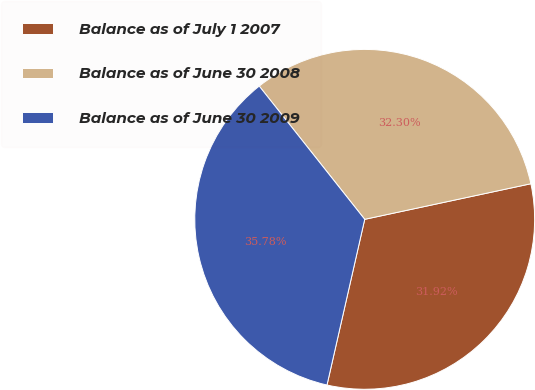<chart> <loc_0><loc_0><loc_500><loc_500><pie_chart><fcel>Balance as of July 1 2007<fcel>Balance as of June 30 2008<fcel>Balance as of June 30 2009<nl><fcel>31.92%<fcel>32.3%<fcel>35.78%<nl></chart> 